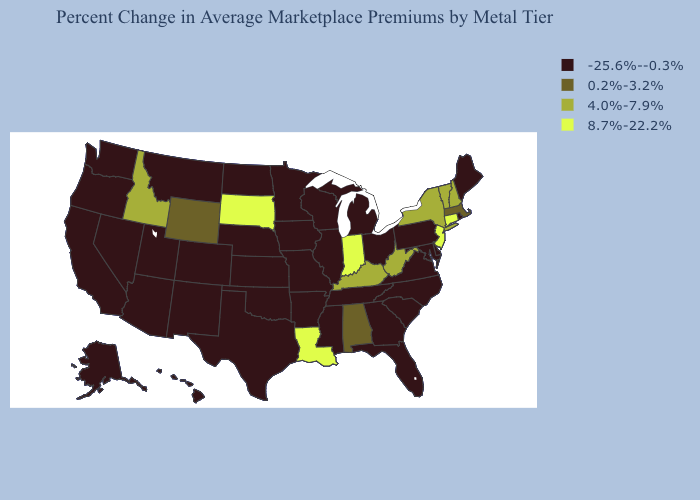What is the value of Alaska?
Keep it brief. -25.6%--0.3%. Name the states that have a value in the range 8.7%-22.2%?
Give a very brief answer. Connecticut, Indiana, Louisiana, New Jersey, South Dakota. Name the states that have a value in the range 0.2%-3.2%?
Write a very short answer. Alabama, Massachusetts, Wyoming. What is the value of Delaware?
Quick response, please. -25.6%--0.3%. What is the value of Pennsylvania?
Write a very short answer. -25.6%--0.3%. What is the value of Massachusetts?
Be succinct. 0.2%-3.2%. Name the states that have a value in the range 4.0%-7.9%?
Write a very short answer. Idaho, Kentucky, New Hampshire, New York, Vermont, West Virginia. What is the highest value in the South ?
Short answer required. 8.7%-22.2%. What is the value of Oklahoma?
Give a very brief answer. -25.6%--0.3%. Is the legend a continuous bar?
Write a very short answer. No. What is the value of Arkansas?
Concise answer only. -25.6%--0.3%. Name the states that have a value in the range 0.2%-3.2%?
Short answer required. Alabama, Massachusetts, Wyoming. What is the value of Virginia?
Keep it brief. -25.6%--0.3%. What is the value of Nevada?
Write a very short answer. -25.6%--0.3%. Name the states that have a value in the range 8.7%-22.2%?
Write a very short answer. Connecticut, Indiana, Louisiana, New Jersey, South Dakota. 